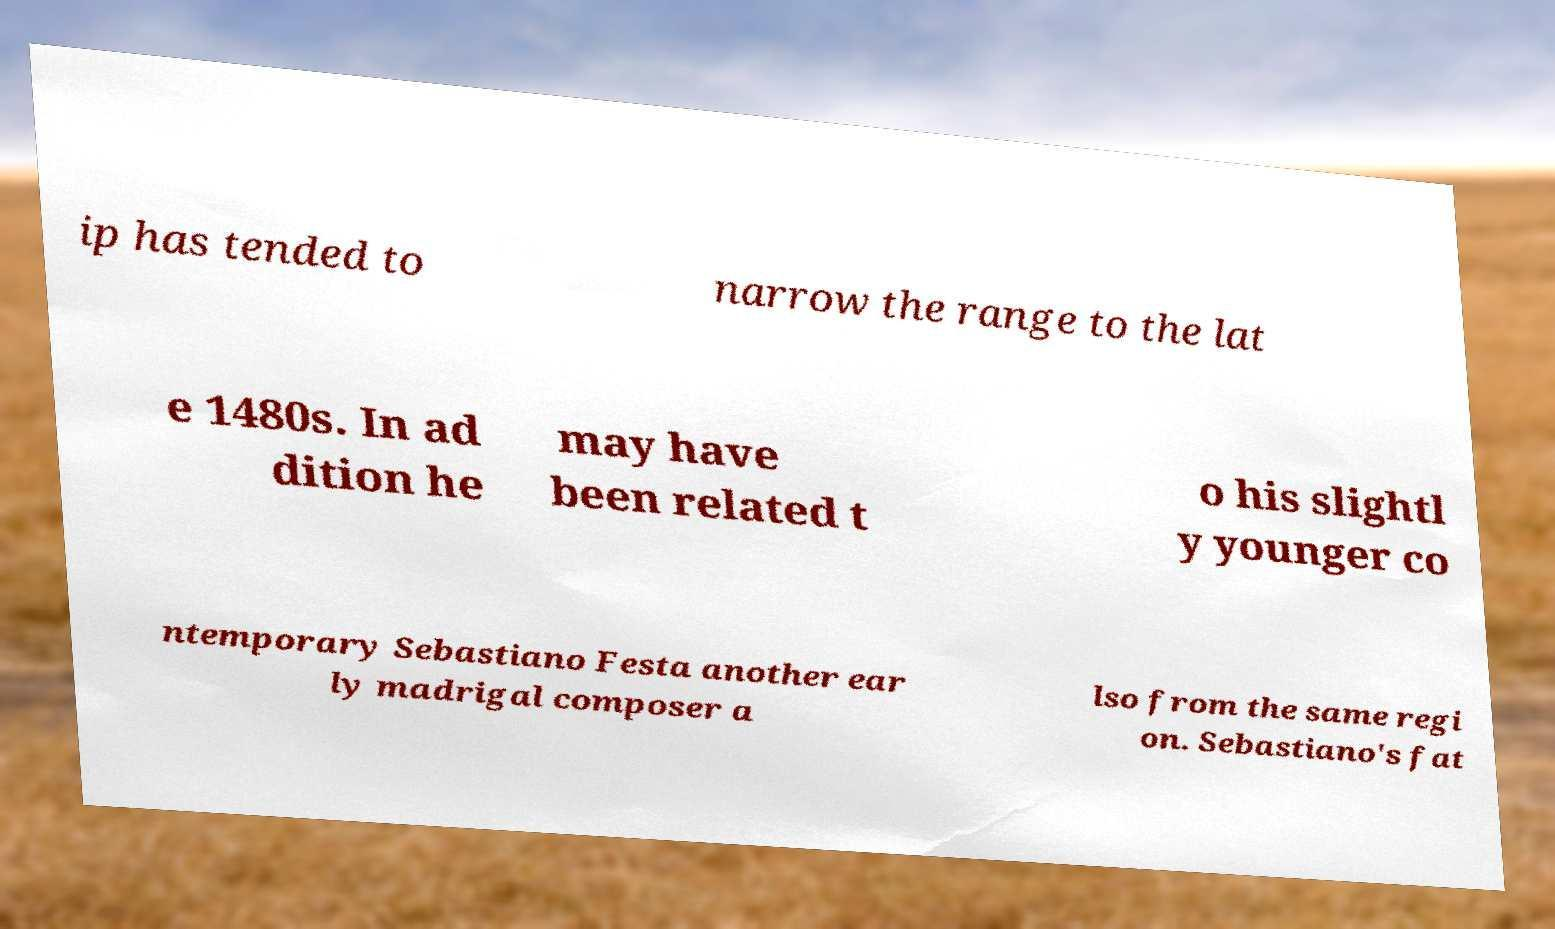Please identify and transcribe the text found in this image. ip has tended to narrow the range to the lat e 1480s. In ad dition he may have been related t o his slightl y younger co ntemporary Sebastiano Festa another ear ly madrigal composer a lso from the same regi on. Sebastiano's fat 